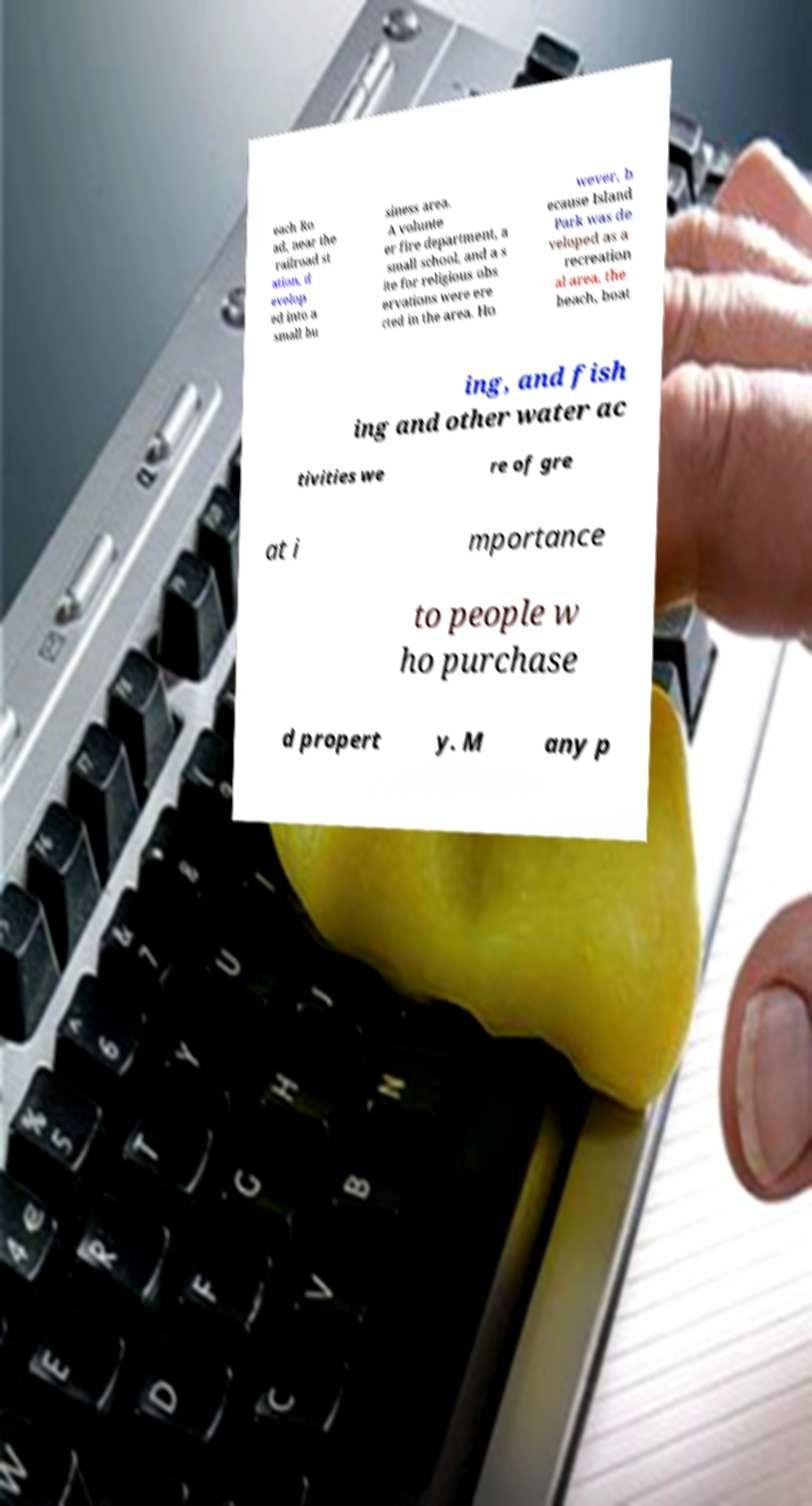Could you assist in decoding the text presented in this image and type it out clearly? each Ro ad, near the railroad st ation, d evelop ed into a small bu siness area. A volunte er fire department, a small school, and a s ite for religious obs ervations were ere cted in the area. Ho wever, b ecause Island Park was de veloped as a recreation al area, the beach, boat ing, and fish ing and other water ac tivities we re of gre at i mportance to people w ho purchase d propert y. M any p 